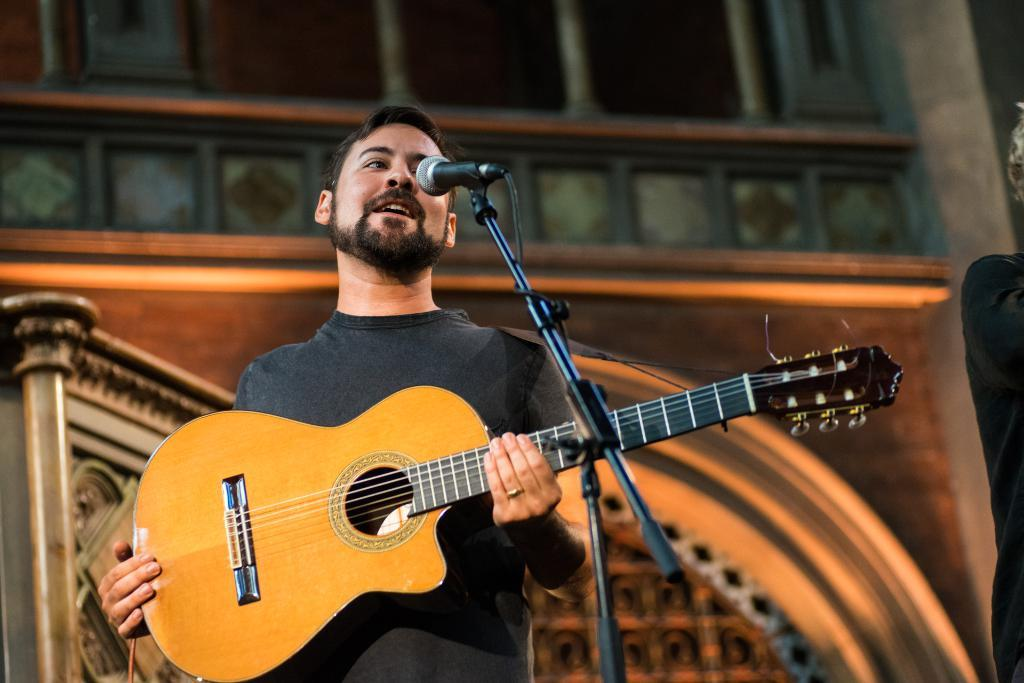What is the man in the image doing? The man is playing a guitar and singing into a microphone. What instrument is the man playing in the image? The man is playing a guitar. Is the man performing any vocal activity in the image? Yes, the man is singing into a microphone. What type of canvas is the man painting on in the image? There is no canvas present in the image; the man is playing a guitar and singing into a microphone. 